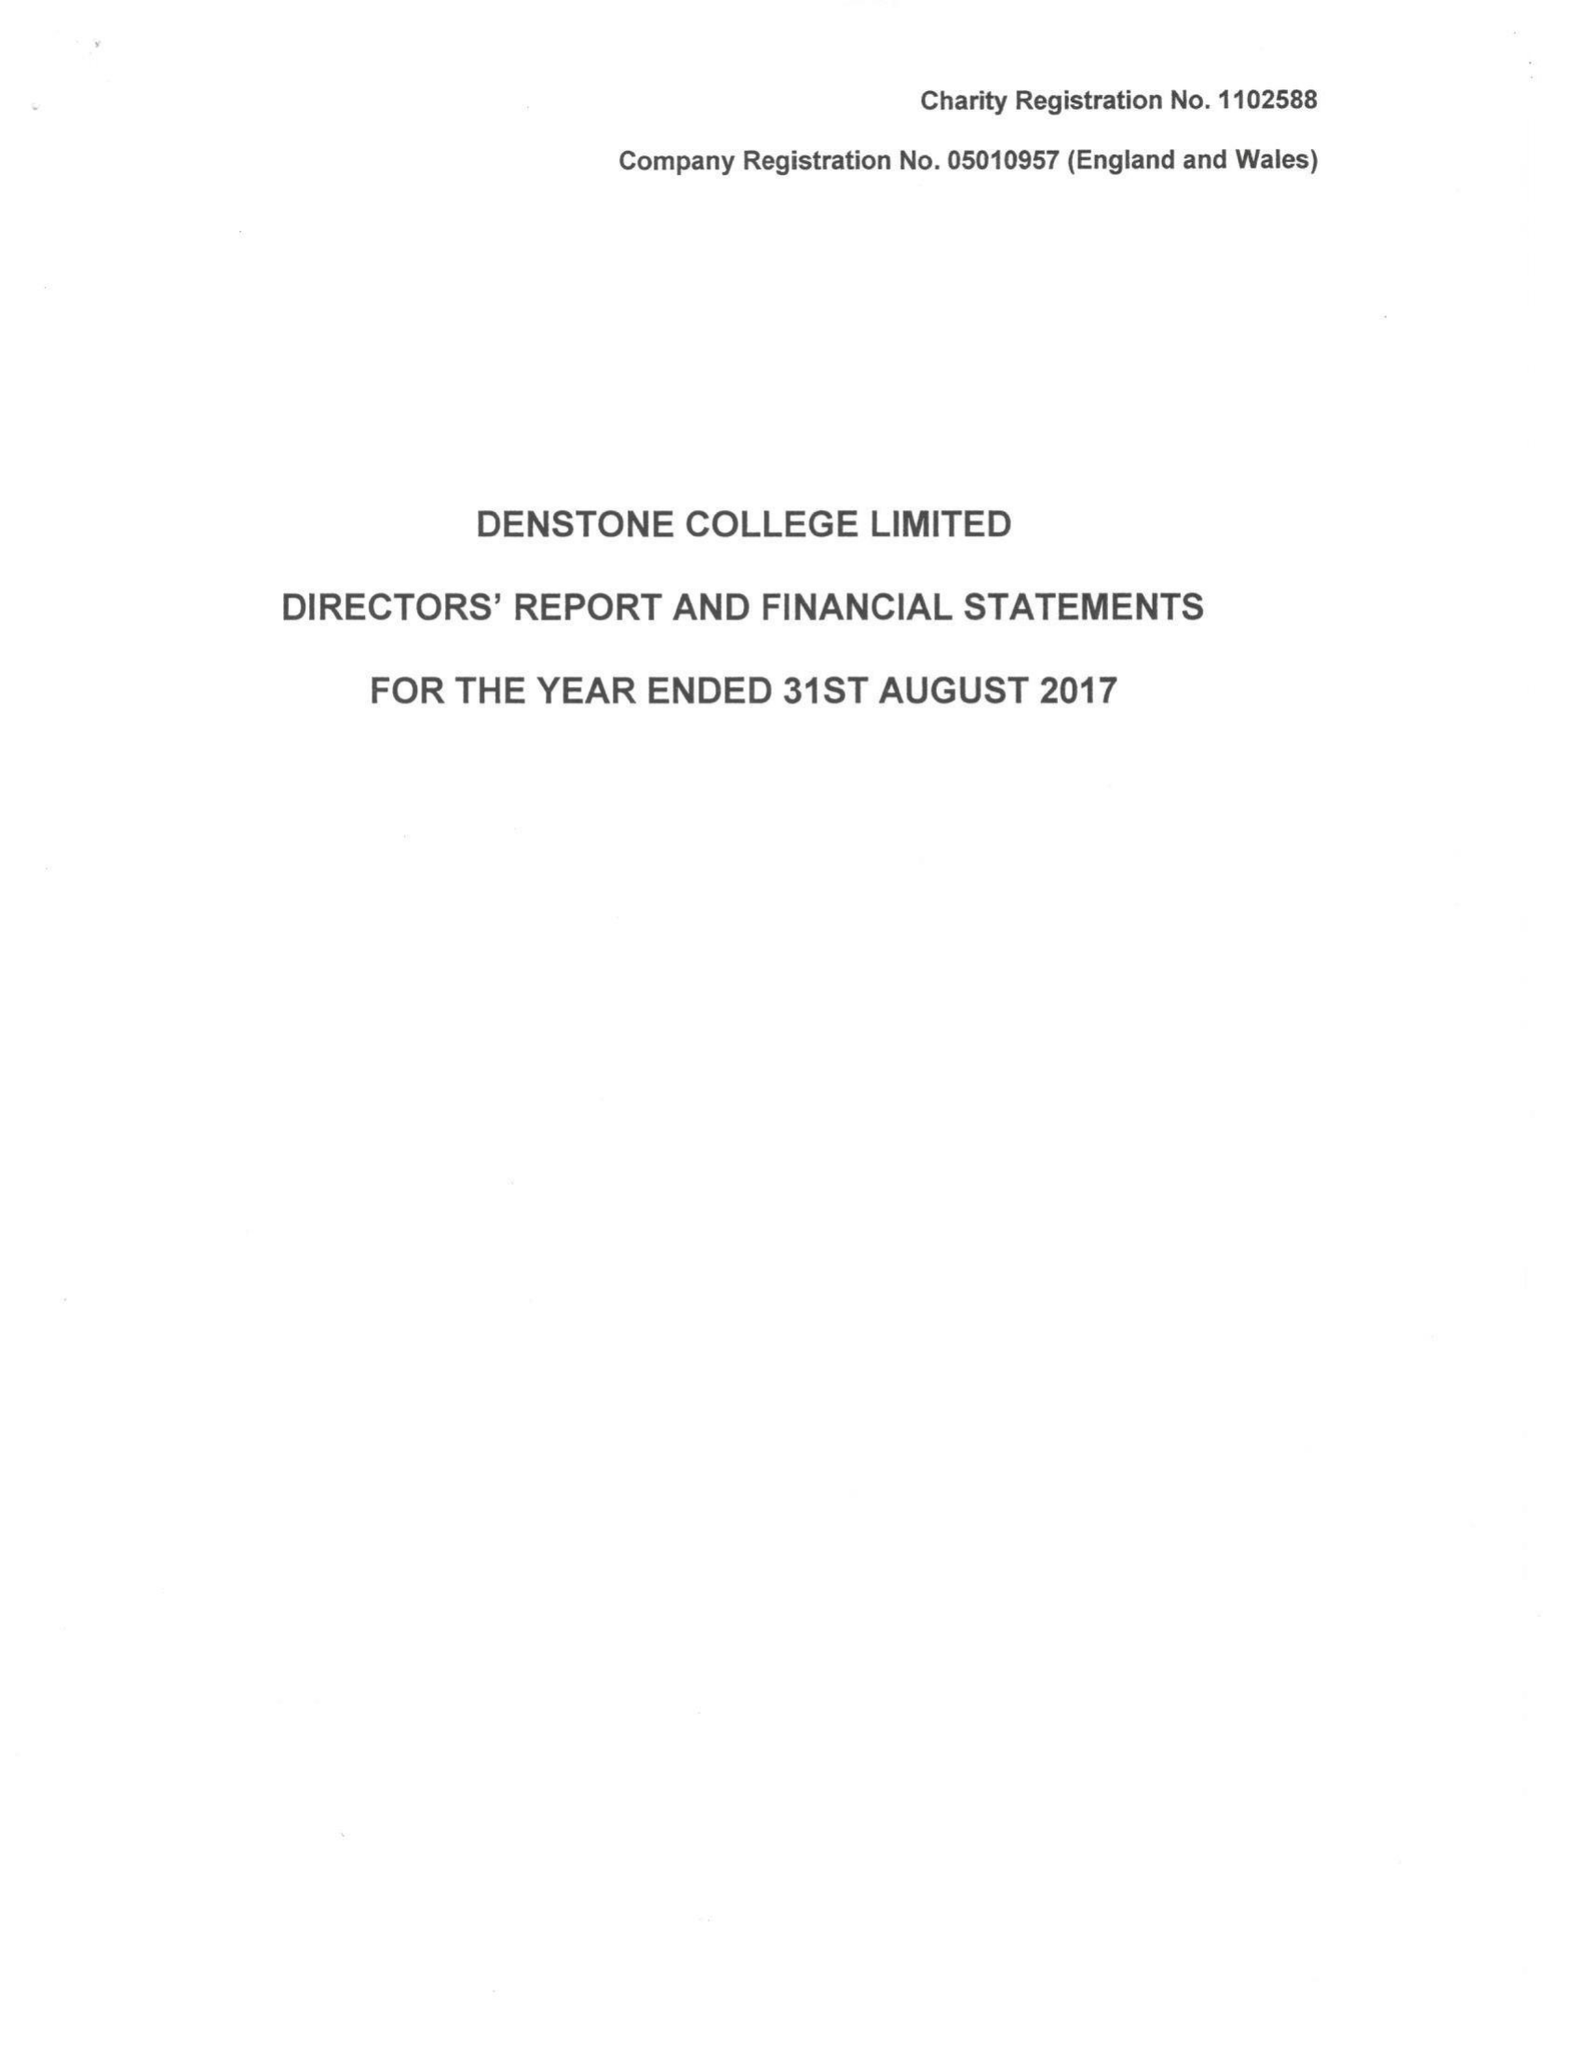What is the value for the address__postcode?
Answer the question using a single word or phrase. ST14 5HN 